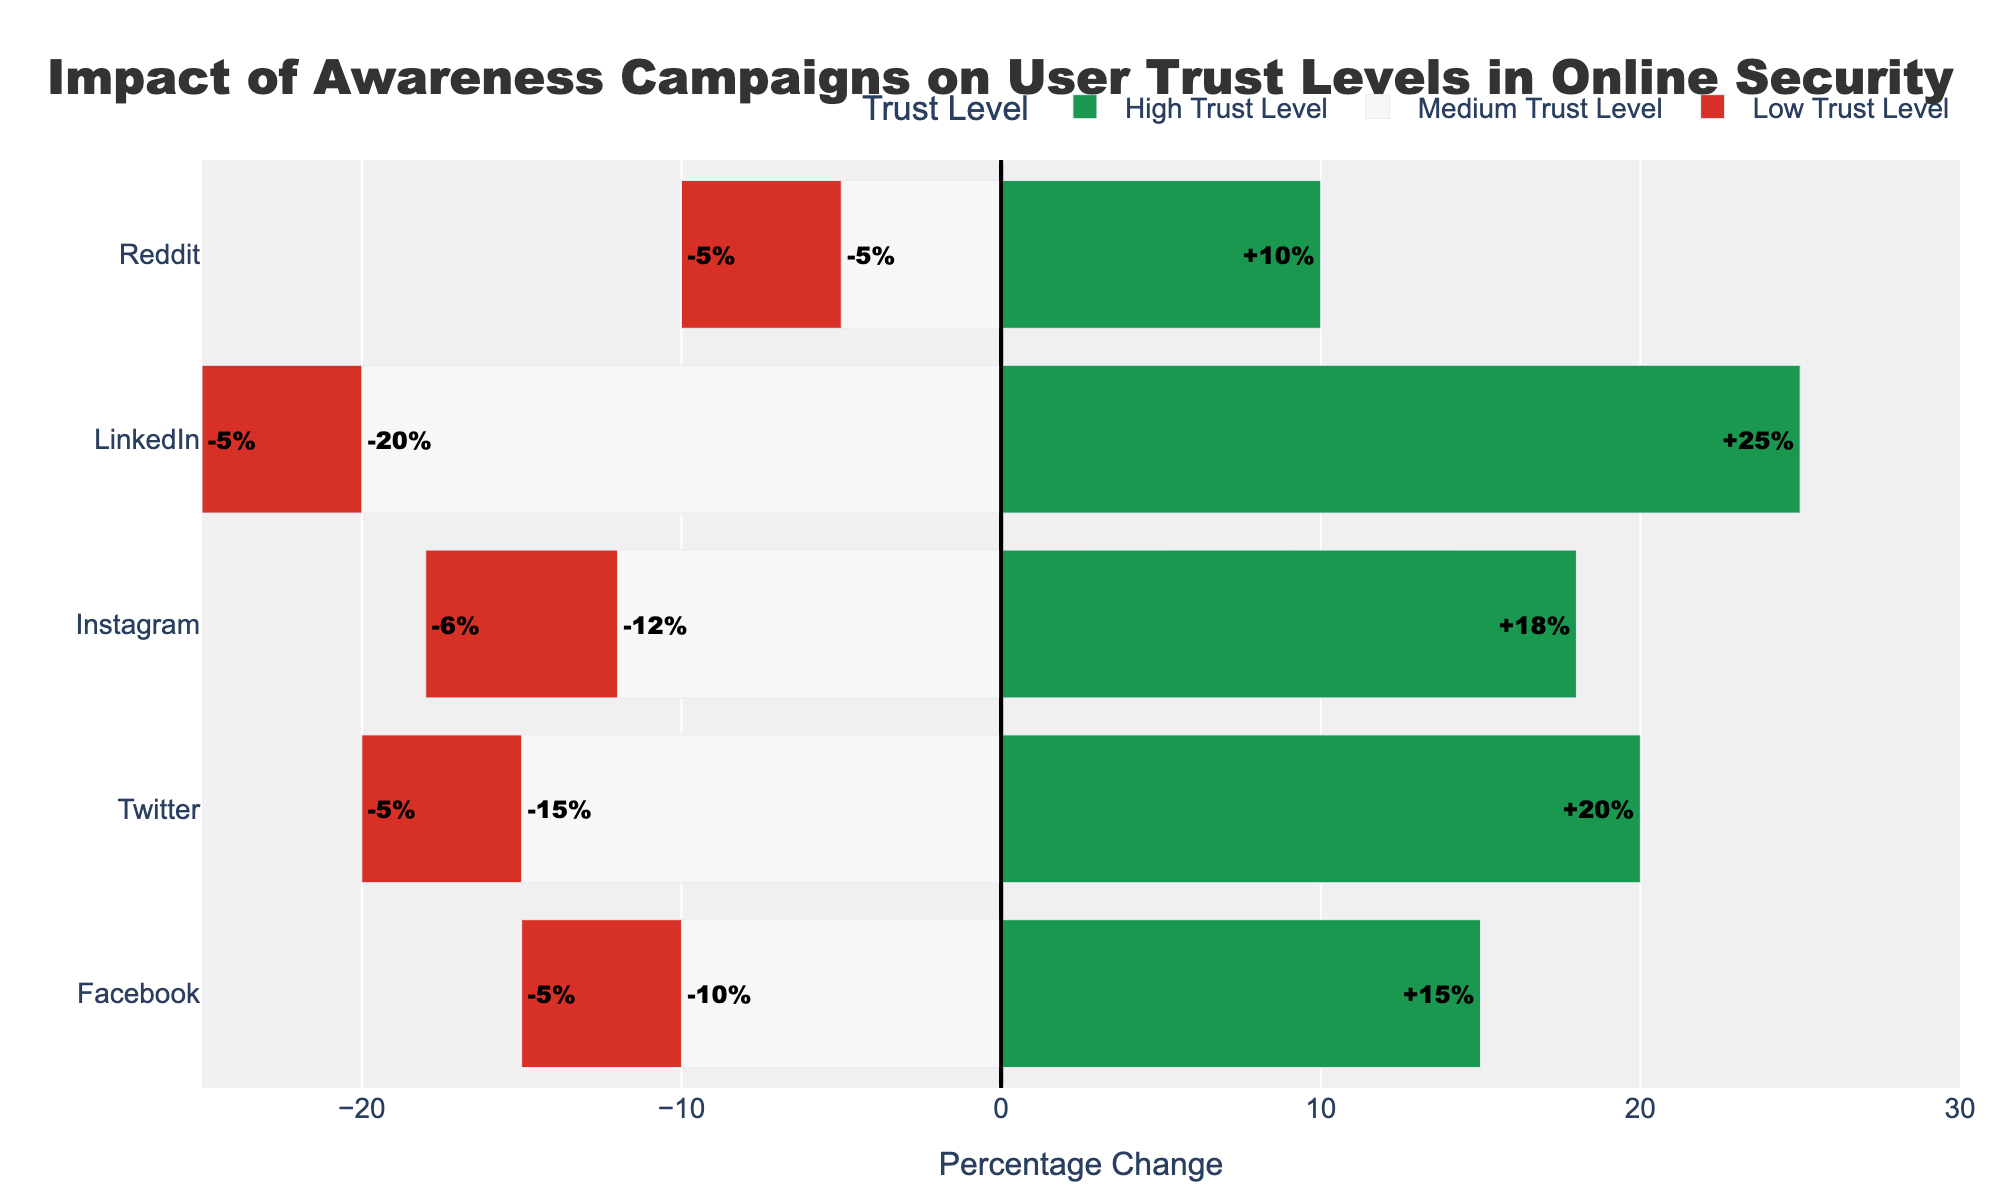What is the percentage change for the high trust level on LinkedIn? Look for the bar corresponding to "High Trust Level" on LinkedIn and read off the percentage change. LinkedIn's high trust level bar indicates a change of +25%.
Answer: 25% Which platform shows the highest increase in high trust levels? Compare the lengths of the green bars (representing high trust levels) across all platforms. LinkedIn exhibits the highest increase at +25%.
Answer: LinkedIn How does the change in medium trust levels on Twitter compare to Instagram? Locate the bars for "Medium Trust Level" on both Twitter and Instagram. Twitter shows a -15% change while Instagram shows a -12% change. Comparing these, Twitter has a larger decrease.
Answer: Twitter has a larger decrease What is the total percentage change in trust levels for Facebook? Sum the percentage changes for high, medium, and low trust levels on Facebook: 15 + (-10) + (-5) = 0%.
Answer: 0% Which platform has the least change in low trust levels? Compare the bars for "Low Trust Level" across all platforms. All platforms have a -5% change in low trust levels, so none have a lesser change.
Answer: All equal Which platform shows the least improvement in high trust levels? Compare the green bars (high trust levels) for each platform. Reddit shows the least improvement with a +10% change.
Answer: Reddit On which platform did medium trust levels decrease the most? Check the lengths and values of the bars for "Medium Trust Level" and find the platform with the greatest negative value. LinkedIn has the largest decrease with -20%.
Answer: LinkedIn What is the combined percentage change for medium trust levels across all platforms? Add up the percentage changes for medium trust levels: (-10) + (-15) + (-12) + (-20) + (-5) = -62%.
Answer: -62% What colors represent the trust levels on the chart? Identify the colors used for the different trust levels. Green represents high trust levels, gray represents medium trust levels, and red represents low trust levels.
Answer: Green, Gray, Red Which platform shows the largest difference between the increases in high trust and decreases in medium trust levels? Find the absolute differences between the high trust increases and medium trust decreases for all platforms, then identify the largest one. LinkedIn shows a high trust increase of 25% and medium trust decrease of 20%, making the difference 45%.
Answer: LinkedIn 